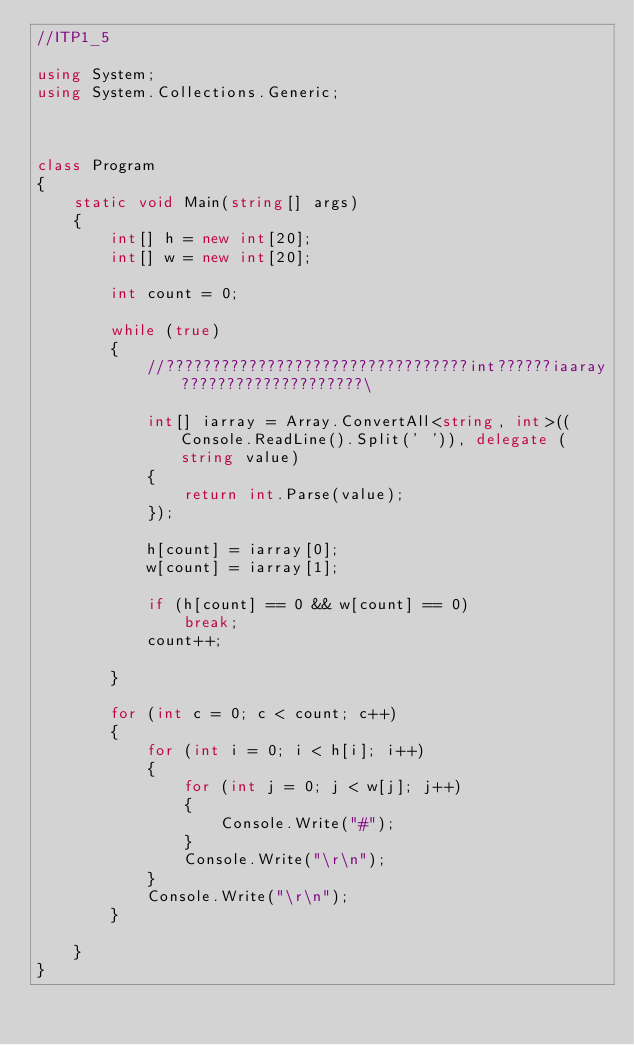<code> <loc_0><loc_0><loc_500><loc_500><_C#_>//ITP1_5

using System;
using System.Collections.Generic;



class Program
{
    static void Main(string[] args)
    {
        int[] h = new int[20];
        int[] w = new int[20];

        int count = 0;

        while (true)
        {
            //?????????????????????????????????int??????iaaray????????????????????\

            int[] iarray = Array.ConvertAll<string, int>((Console.ReadLine().Split(' ')), delegate (string value)
            {
                return int.Parse(value);
            });
                
            h[count] = iarray[0];
            w[count] = iarray[1];

            if (h[count] == 0 && w[count] == 0)
                break;
            count++;

        }

        for (int c = 0; c < count; c++)
        {
            for (int i = 0; i < h[i]; i++)
            {
                for (int j = 0; j < w[j]; j++)
                {
                    Console.Write("#");
                }
                Console.Write("\r\n");
            }
            Console.Write("\r\n");
        }

    }
}</code> 